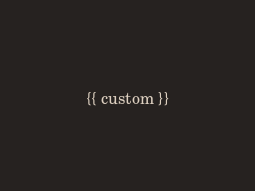<code> <loc_0><loc_0><loc_500><loc_500><_HTML_>{{ custom }}
</code> 